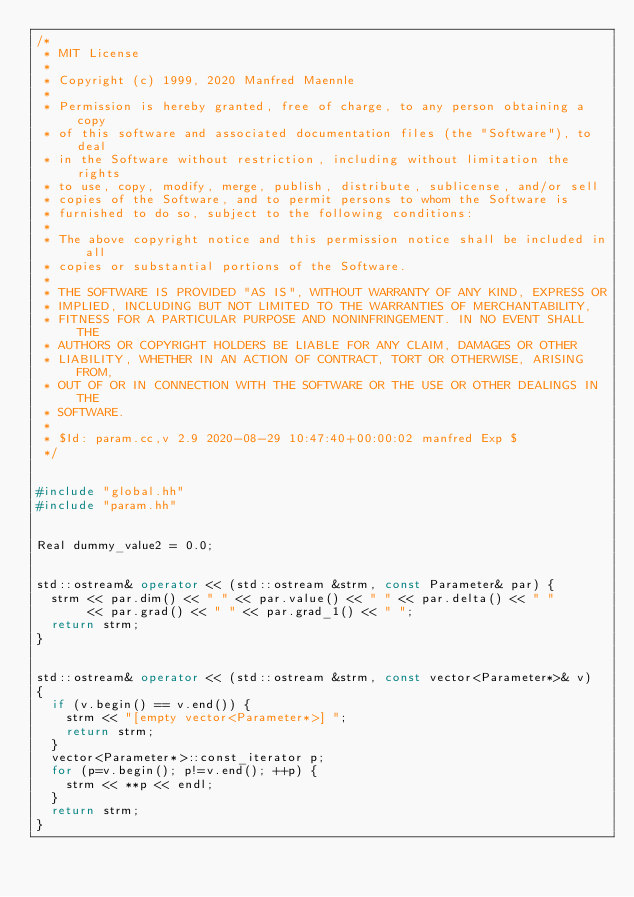<code> <loc_0><loc_0><loc_500><loc_500><_C++_>/*
 * MIT License
 *
 * Copyright (c) 1999, 2020 Manfred Maennle
 * 
 * Permission is hereby granted, free of charge, to any person obtaining a copy
 * of this software and associated documentation files (the "Software"), to deal
 * in the Software without restriction, including without limitation the rights
 * to use, copy, modify, merge, publish, distribute, sublicense, and/or sell
 * copies of the Software, and to permit persons to whom the Software is
 * furnished to do so, subject to the following conditions:
 * 
 * The above copyright notice and this permission notice shall be included in all
 * copies or substantial portions of the Software.
 * 
 * THE SOFTWARE IS PROVIDED "AS IS", WITHOUT WARRANTY OF ANY KIND, EXPRESS OR
 * IMPLIED, INCLUDING BUT NOT LIMITED TO THE WARRANTIES OF MERCHANTABILITY,
 * FITNESS FOR A PARTICULAR PURPOSE AND NONINFRINGEMENT. IN NO EVENT SHALL THE
 * AUTHORS OR COPYRIGHT HOLDERS BE LIABLE FOR ANY CLAIM, DAMAGES OR OTHER
 * LIABILITY, WHETHER IN AN ACTION OF CONTRACT, TORT OR OTHERWISE, ARISING FROM,
 * OUT OF OR IN CONNECTION WITH THE SOFTWARE OR THE USE OR OTHER DEALINGS IN THE
 * SOFTWARE.
 *
 * $Id: param.cc,v 2.9 2020-08-29 10:47:40+00:00:02 manfred Exp $
 */


#include "global.hh"
#include "param.hh"


Real dummy_value2 = 0.0;


std::ostream& operator << (std::ostream &strm, const Parameter& par) {
  strm << par.dim() << " " << par.value() << " " << par.delta() << " " 
       << par.grad() << " " << par.grad_1() << " ";
  return strm;
}


std::ostream& operator << (std::ostream &strm, const vector<Parameter*>& v)
{
  if (v.begin() == v.end()) {
    strm << "[empty vector<Parameter*>] ";
    return strm;
  }
  vector<Parameter*>::const_iterator p;
  for (p=v.begin(); p!=v.end(); ++p) {
    strm << **p << endl;
  }
  return strm;
}
</code> 